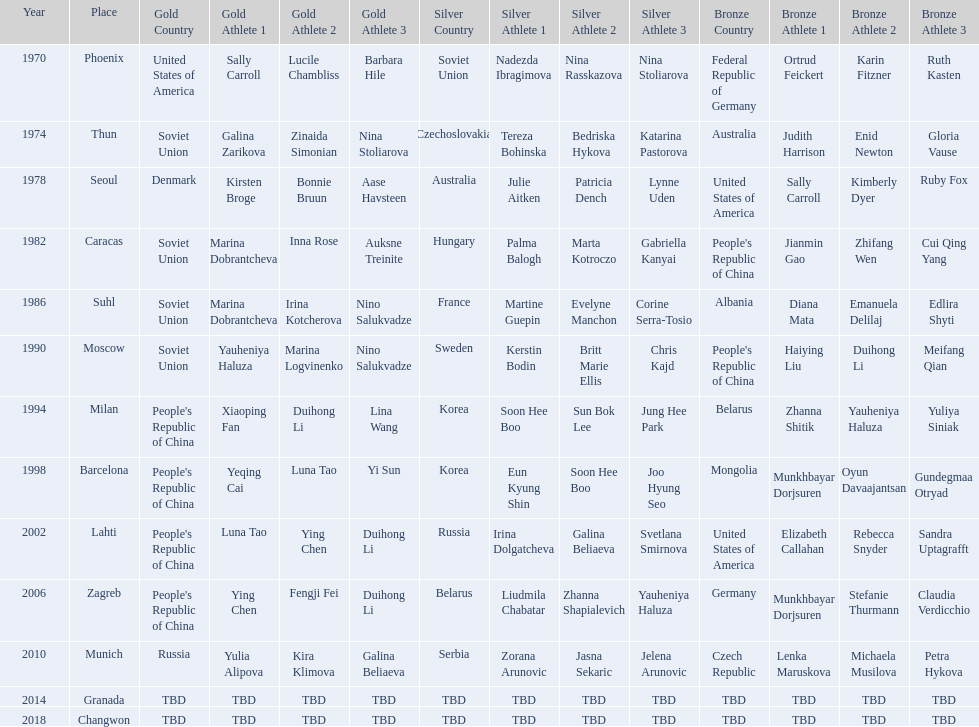Which country is listed the most under the silver column? Korea. 